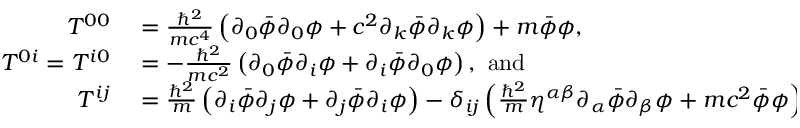Convert formula to latex. <formula><loc_0><loc_0><loc_500><loc_500>\begin{array} { r l } { T ^ { 0 0 } } & = { \frac { \hbar { ^ } { 2 } } { m c ^ { 4 } } } \left ( \partial _ { 0 } { \bar { \phi } } \partial _ { 0 } \phi + c ^ { 2 } \partial _ { k } { \bar { \phi } } \partial _ { k } \phi \right ) + m { \bar { \phi } } \phi , } \\ { T ^ { 0 i } = T ^ { i 0 } } & = - { \frac { \hbar { ^ } { 2 } } { m c ^ { 2 } } } \left ( \partial _ { 0 } { \bar { \phi } } \partial _ { i } \phi + \partial _ { i } { \bar { \phi } } \partial _ { 0 } \phi \right ) , \ a n d } \\ { T ^ { i j } } & = { \frac { \hbar { ^ } { 2 } } { m } } \left ( \partial _ { i } { \bar { \phi } } \partial _ { j } \phi + \partial _ { j } { \bar { \phi } } \partial _ { i } \phi \right ) - \delta _ { i j } \left ( { \frac { \hbar { ^ } { 2 } } { m } } \eta ^ { \alpha \beta } \partial _ { \alpha } { \bar { \phi } } \partial _ { \beta } \phi + m c ^ { 2 } { \bar { \phi } } \phi \right ) . } \end{array}</formula> 